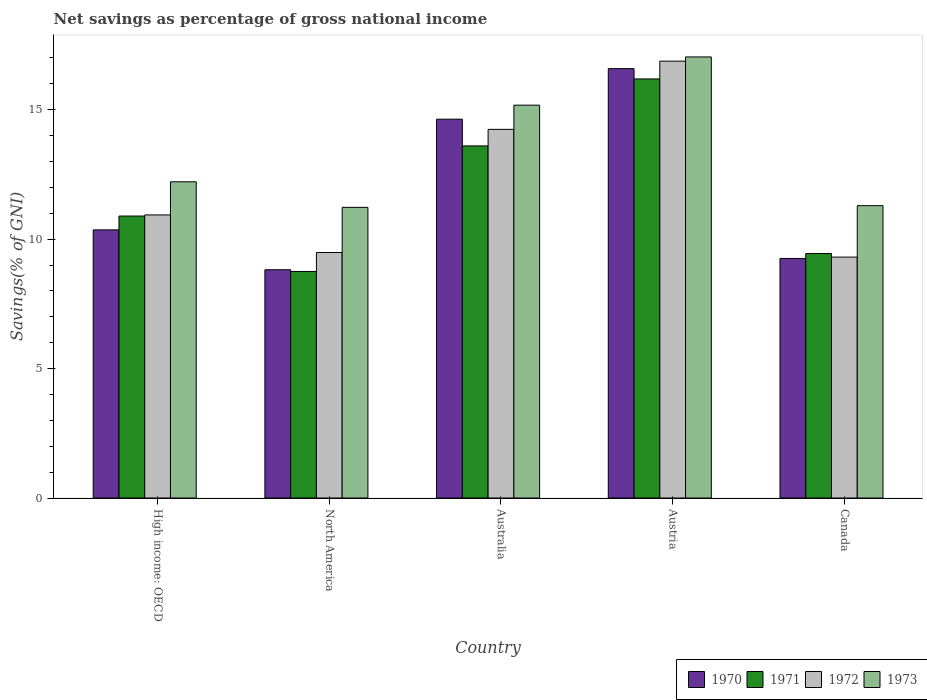How many groups of bars are there?
Your answer should be compact. 5. Are the number of bars per tick equal to the number of legend labels?
Your answer should be compact. Yes. Are the number of bars on each tick of the X-axis equal?
Provide a succinct answer. Yes. How many bars are there on the 2nd tick from the left?
Ensure brevity in your answer.  4. How many bars are there on the 4th tick from the right?
Your answer should be very brief. 4. In how many cases, is the number of bars for a given country not equal to the number of legend labels?
Give a very brief answer. 0. What is the total savings in 1970 in Australia?
Keep it short and to the point. 14.63. Across all countries, what is the maximum total savings in 1970?
Your answer should be very brief. 16.59. Across all countries, what is the minimum total savings in 1971?
Offer a terse response. 8.75. What is the total total savings in 1973 in the graph?
Your response must be concise. 66.95. What is the difference between the total savings in 1972 in Australia and that in Canada?
Give a very brief answer. 4.94. What is the difference between the total savings in 1973 in Australia and the total savings in 1970 in North America?
Your answer should be very brief. 6.36. What is the average total savings in 1971 per country?
Give a very brief answer. 11.78. What is the difference between the total savings of/in 1972 and total savings of/in 1973 in North America?
Your response must be concise. -1.74. What is the ratio of the total savings in 1973 in Australia to that in North America?
Your answer should be very brief. 1.35. Is the total savings in 1973 in Australia less than that in Canada?
Make the answer very short. No. What is the difference between the highest and the second highest total savings in 1970?
Give a very brief answer. 6.23. What is the difference between the highest and the lowest total savings in 1971?
Your answer should be compact. 7.44. Is the sum of the total savings in 1973 in Canada and North America greater than the maximum total savings in 1972 across all countries?
Make the answer very short. Yes. Is it the case that in every country, the sum of the total savings in 1970 and total savings in 1972 is greater than the sum of total savings in 1973 and total savings in 1971?
Your response must be concise. No. How many countries are there in the graph?
Ensure brevity in your answer.  5. What is the difference between two consecutive major ticks on the Y-axis?
Your answer should be very brief. 5. Does the graph contain any zero values?
Make the answer very short. No. Does the graph contain grids?
Your response must be concise. No. Where does the legend appear in the graph?
Offer a terse response. Bottom right. What is the title of the graph?
Keep it short and to the point. Net savings as percentage of gross national income. What is the label or title of the Y-axis?
Your response must be concise. Savings(% of GNI). What is the Savings(% of GNI) of 1970 in High income: OECD?
Your answer should be compact. 10.36. What is the Savings(% of GNI) of 1971 in High income: OECD?
Keep it short and to the point. 10.89. What is the Savings(% of GNI) in 1972 in High income: OECD?
Your answer should be very brief. 10.94. What is the Savings(% of GNI) in 1973 in High income: OECD?
Provide a short and direct response. 12.22. What is the Savings(% of GNI) of 1970 in North America?
Provide a short and direct response. 8.82. What is the Savings(% of GNI) in 1971 in North America?
Provide a succinct answer. 8.75. What is the Savings(% of GNI) of 1972 in North America?
Keep it short and to the point. 9.48. What is the Savings(% of GNI) of 1973 in North America?
Your response must be concise. 11.23. What is the Savings(% of GNI) in 1970 in Australia?
Keep it short and to the point. 14.63. What is the Savings(% of GNI) in 1971 in Australia?
Your answer should be very brief. 13.6. What is the Savings(% of GNI) of 1972 in Australia?
Your response must be concise. 14.24. What is the Savings(% of GNI) of 1973 in Australia?
Your answer should be very brief. 15.18. What is the Savings(% of GNI) in 1970 in Austria?
Offer a terse response. 16.59. What is the Savings(% of GNI) of 1971 in Austria?
Provide a short and direct response. 16.19. What is the Savings(% of GNI) in 1972 in Austria?
Make the answer very short. 16.88. What is the Savings(% of GNI) of 1973 in Austria?
Your response must be concise. 17.04. What is the Savings(% of GNI) in 1970 in Canada?
Ensure brevity in your answer.  9.25. What is the Savings(% of GNI) in 1971 in Canada?
Your response must be concise. 9.45. What is the Savings(% of GNI) of 1972 in Canada?
Make the answer very short. 9.31. What is the Savings(% of GNI) in 1973 in Canada?
Your answer should be very brief. 11.29. Across all countries, what is the maximum Savings(% of GNI) of 1970?
Your answer should be compact. 16.59. Across all countries, what is the maximum Savings(% of GNI) in 1971?
Give a very brief answer. 16.19. Across all countries, what is the maximum Savings(% of GNI) of 1972?
Offer a very short reply. 16.88. Across all countries, what is the maximum Savings(% of GNI) of 1973?
Your response must be concise. 17.04. Across all countries, what is the minimum Savings(% of GNI) of 1970?
Offer a very short reply. 8.82. Across all countries, what is the minimum Savings(% of GNI) of 1971?
Your answer should be very brief. 8.75. Across all countries, what is the minimum Savings(% of GNI) in 1972?
Provide a succinct answer. 9.31. Across all countries, what is the minimum Savings(% of GNI) in 1973?
Keep it short and to the point. 11.23. What is the total Savings(% of GNI) of 1970 in the graph?
Your answer should be compact. 59.65. What is the total Savings(% of GNI) of 1971 in the graph?
Ensure brevity in your answer.  58.88. What is the total Savings(% of GNI) in 1972 in the graph?
Provide a short and direct response. 60.84. What is the total Savings(% of GNI) in 1973 in the graph?
Make the answer very short. 66.95. What is the difference between the Savings(% of GNI) in 1970 in High income: OECD and that in North America?
Keep it short and to the point. 1.54. What is the difference between the Savings(% of GNI) in 1971 in High income: OECD and that in North America?
Make the answer very short. 2.14. What is the difference between the Savings(% of GNI) of 1972 in High income: OECD and that in North America?
Keep it short and to the point. 1.45. What is the difference between the Savings(% of GNI) in 1973 in High income: OECD and that in North America?
Your response must be concise. 0.99. What is the difference between the Savings(% of GNI) in 1970 in High income: OECD and that in Australia?
Offer a terse response. -4.28. What is the difference between the Savings(% of GNI) in 1971 in High income: OECD and that in Australia?
Provide a succinct answer. -2.71. What is the difference between the Savings(% of GNI) of 1972 in High income: OECD and that in Australia?
Give a very brief answer. -3.31. What is the difference between the Savings(% of GNI) in 1973 in High income: OECD and that in Australia?
Give a very brief answer. -2.96. What is the difference between the Savings(% of GNI) of 1970 in High income: OECD and that in Austria?
Offer a terse response. -6.23. What is the difference between the Savings(% of GNI) of 1971 in High income: OECD and that in Austria?
Provide a succinct answer. -5.3. What is the difference between the Savings(% of GNI) in 1972 in High income: OECD and that in Austria?
Keep it short and to the point. -5.94. What is the difference between the Savings(% of GNI) in 1973 in High income: OECD and that in Austria?
Your response must be concise. -4.82. What is the difference between the Savings(% of GNI) in 1970 in High income: OECD and that in Canada?
Provide a short and direct response. 1.1. What is the difference between the Savings(% of GNI) in 1971 in High income: OECD and that in Canada?
Provide a short and direct response. 1.45. What is the difference between the Savings(% of GNI) in 1972 in High income: OECD and that in Canada?
Offer a very short reply. 1.63. What is the difference between the Savings(% of GNI) in 1973 in High income: OECD and that in Canada?
Give a very brief answer. 0.92. What is the difference between the Savings(% of GNI) in 1970 in North America and that in Australia?
Give a very brief answer. -5.82. What is the difference between the Savings(% of GNI) in 1971 in North America and that in Australia?
Ensure brevity in your answer.  -4.85. What is the difference between the Savings(% of GNI) in 1972 in North America and that in Australia?
Give a very brief answer. -4.76. What is the difference between the Savings(% of GNI) in 1973 in North America and that in Australia?
Give a very brief answer. -3.95. What is the difference between the Savings(% of GNI) of 1970 in North America and that in Austria?
Provide a short and direct response. -7.77. What is the difference between the Savings(% of GNI) of 1971 in North America and that in Austria?
Offer a terse response. -7.44. What is the difference between the Savings(% of GNI) in 1972 in North America and that in Austria?
Offer a very short reply. -7.39. What is the difference between the Savings(% of GNI) in 1973 in North America and that in Austria?
Provide a succinct answer. -5.81. What is the difference between the Savings(% of GNI) of 1970 in North America and that in Canada?
Give a very brief answer. -0.44. What is the difference between the Savings(% of GNI) of 1971 in North America and that in Canada?
Provide a short and direct response. -0.69. What is the difference between the Savings(% of GNI) of 1972 in North America and that in Canada?
Offer a very short reply. 0.18. What is the difference between the Savings(% of GNI) in 1973 in North America and that in Canada?
Your answer should be compact. -0.07. What is the difference between the Savings(% of GNI) in 1970 in Australia and that in Austria?
Your answer should be very brief. -1.95. What is the difference between the Savings(% of GNI) in 1971 in Australia and that in Austria?
Provide a succinct answer. -2.59. What is the difference between the Savings(% of GNI) in 1972 in Australia and that in Austria?
Provide a succinct answer. -2.64. What is the difference between the Savings(% of GNI) in 1973 in Australia and that in Austria?
Provide a succinct answer. -1.86. What is the difference between the Savings(% of GNI) in 1970 in Australia and that in Canada?
Provide a succinct answer. 5.38. What is the difference between the Savings(% of GNI) of 1971 in Australia and that in Canada?
Provide a short and direct response. 4.16. What is the difference between the Savings(% of GNI) of 1972 in Australia and that in Canada?
Ensure brevity in your answer.  4.93. What is the difference between the Savings(% of GNI) in 1973 in Australia and that in Canada?
Provide a succinct answer. 3.88. What is the difference between the Savings(% of GNI) of 1970 in Austria and that in Canada?
Ensure brevity in your answer.  7.33. What is the difference between the Savings(% of GNI) of 1971 in Austria and that in Canada?
Ensure brevity in your answer.  6.74. What is the difference between the Savings(% of GNI) in 1972 in Austria and that in Canada?
Offer a terse response. 7.57. What is the difference between the Savings(% of GNI) in 1973 in Austria and that in Canada?
Provide a succinct answer. 5.75. What is the difference between the Savings(% of GNI) of 1970 in High income: OECD and the Savings(% of GNI) of 1971 in North America?
Offer a very short reply. 1.61. What is the difference between the Savings(% of GNI) of 1970 in High income: OECD and the Savings(% of GNI) of 1972 in North America?
Offer a very short reply. 0.87. What is the difference between the Savings(% of GNI) of 1970 in High income: OECD and the Savings(% of GNI) of 1973 in North America?
Provide a short and direct response. -0.87. What is the difference between the Savings(% of GNI) of 1971 in High income: OECD and the Savings(% of GNI) of 1972 in North America?
Your response must be concise. 1.41. What is the difference between the Savings(% of GNI) in 1971 in High income: OECD and the Savings(% of GNI) in 1973 in North America?
Ensure brevity in your answer.  -0.34. What is the difference between the Savings(% of GNI) of 1972 in High income: OECD and the Savings(% of GNI) of 1973 in North America?
Give a very brief answer. -0.29. What is the difference between the Savings(% of GNI) of 1970 in High income: OECD and the Savings(% of GNI) of 1971 in Australia?
Ensure brevity in your answer.  -3.24. What is the difference between the Savings(% of GNI) of 1970 in High income: OECD and the Savings(% of GNI) of 1972 in Australia?
Your answer should be very brief. -3.88. What is the difference between the Savings(% of GNI) of 1970 in High income: OECD and the Savings(% of GNI) of 1973 in Australia?
Provide a short and direct response. -4.82. What is the difference between the Savings(% of GNI) of 1971 in High income: OECD and the Savings(% of GNI) of 1972 in Australia?
Make the answer very short. -3.35. What is the difference between the Savings(% of GNI) in 1971 in High income: OECD and the Savings(% of GNI) in 1973 in Australia?
Keep it short and to the point. -4.28. What is the difference between the Savings(% of GNI) of 1972 in High income: OECD and the Savings(% of GNI) of 1973 in Australia?
Your response must be concise. -4.24. What is the difference between the Savings(% of GNI) of 1970 in High income: OECD and the Savings(% of GNI) of 1971 in Austria?
Your answer should be very brief. -5.83. What is the difference between the Savings(% of GNI) in 1970 in High income: OECD and the Savings(% of GNI) in 1972 in Austria?
Provide a succinct answer. -6.52. What is the difference between the Savings(% of GNI) in 1970 in High income: OECD and the Savings(% of GNI) in 1973 in Austria?
Provide a short and direct response. -6.68. What is the difference between the Savings(% of GNI) in 1971 in High income: OECD and the Savings(% of GNI) in 1972 in Austria?
Offer a very short reply. -5.98. What is the difference between the Savings(% of GNI) in 1971 in High income: OECD and the Savings(% of GNI) in 1973 in Austria?
Give a very brief answer. -6.15. What is the difference between the Savings(% of GNI) of 1972 in High income: OECD and the Savings(% of GNI) of 1973 in Austria?
Your response must be concise. -6.1. What is the difference between the Savings(% of GNI) in 1970 in High income: OECD and the Savings(% of GNI) in 1971 in Canada?
Offer a very short reply. 0.91. What is the difference between the Savings(% of GNI) in 1970 in High income: OECD and the Savings(% of GNI) in 1972 in Canada?
Your answer should be very brief. 1.05. What is the difference between the Savings(% of GNI) in 1970 in High income: OECD and the Savings(% of GNI) in 1973 in Canada?
Offer a terse response. -0.94. What is the difference between the Savings(% of GNI) of 1971 in High income: OECD and the Savings(% of GNI) of 1972 in Canada?
Offer a terse response. 1.59. What is the difference between the Savings(% of GNI) in 1971 in High income: OECD and the Savings(% of GNI) in 1973 in Canada?
Your response must be concise. -0.4. What is the difference between the Savings(% of GNI) of 1972 in High income: OECD and the Savings(% of GNI) of 1973 in Canada?
Your response must be concise. -0.36. What is the difference between the Savings(% of GNI) of 1970 in North America and the Savings(% of GNI) of 1971 in Australia?
Your answer should be compact. -4.78. What is the difference between the Savings(% of GNI) of 1970 in North America and the Savings(% of GNI) of 1972 in Australia?
Keep it short and to the point. -5.42. What is the difference between the Savings(% of GNI) of 1970 in North America and the Savings(% of GNI) of 1973 in Australia?
Make the answer very short. -6.36. What is the difference between the Savings(% of GNI) of 1971 in North America and the Savings(% of GNI) of 1972 in Australia?
Ensure brevity in your answer.  -5.49. What is the difference between the Savings(% of GNI) of 1971 in North America and the Savings(% of GNI) of 1973 in Australia?
Keep it short and to the point. -6.42. What is the difference between the Savings(% of GNI) in 1972 in North America and the Savings(% of GNI) in 1973 in Australia?
Offer a very short reply. -5.69. What is the difference between the Savings(% of GNI) of 1970 in North America and the Savings(% of GNI) of 1971 in Austria?
Offer a very short reply. -7.37. What is the difference between the Savings(% of GNI) of 1970 in North America and the Savings(% of GNI) of 1972 in Austria?
Your answer should be compact. -8.06. What is the difference between the Savings(% of GNI) in 1970 in North America and the Savings(% of GNI) in 1973 in Austria?
Offer a very short reply. -8.22. What is the difference between the Savings(% of GNI) in 1971 in North America and the Savings(% of GNI) in 1972 in Austria?
Your answer should be compact. -8.12. What is the difference between the Savings(% of GNI) in 1971 in North America and the Savings(% of GNI) in 1973 in Austria?
Offer a terse response. -8.29. What is the difference between the Savings(% of GNI) in 1972 in North America and the Savings(% of GNI) in 1973 in Austria?
Offer a terse response. -7.56. What is the difference between the Savings(% of GNI) in 1970 in North America and the Savings(% of GNI) in 1971 in Canada?
Provide a short and direct response. -0.63. What is the difference between the Savings(% of GNI) in 1970 in North America and the Savings(% of GNI) in 1972 in Canada?
Make the answer very short. -0.49. What is the difference between the Savings(% of GNI) in 1970 in North America and the Savings(% of GNI) in 1973 in Canada?
Offer a very short reply. -2.48. What is the difference between the Savings(% of GNI) of 1971 in North America and the Savings(% of GNI) of 1972 in Canada?
Give a very brief answer. -0.55. What is the difference between the Savings(% of GNI) in 1971 in North America and the Savings(% of GNI) in 1973 in Canada?
Your response must be concise. -2.54. What is the difference between the Savings(% of GNI) in 1972 in North America and the Savings(% of GNI) in 1973 in Canada?
Your answer should be very brief. -1.81. What is the difference between the Savings(% of GNI) in 1970 in Australia and the Savings(% of GNI) in 1971 in Austria?
Make the answer very short. -1.55. What is the difference between the Savings(% of GNI) in 1970 in Australia and the Savings(% of GNI) in 1972 in Austria?
Offer a very short reply. -2.24. What is the difference between the Savings(% of GNI) in 1970 in Australia and the Savings(% of GNI) in 1973 in Austria?
Provide a short and direct response. -2.4. What is the difference between the Savings(% of GNI) in 1971 in Australia and the Savings(% of GNI) in 1972 in Austria?
Provide a succinct answer. -3.27. What is the difference between the Savings(% of GNI) in 1971 in Australia and the Savings(% of GNI) in 1973 in Austria?
Give a very brief answer. -3.44. What is the difference between the Savings(% of GNI) of 1972 in Australia and the Savings(% of GNI) of 1973 in Austria?
Your answer should be compact. -2.8. What is the difference between the Savings(% of GNI) in 1970 in Australia and the Savings(% of GNI) in 1971 in Canada?
Keep it short and to the point. 5.19. What is the difference between the Savings(% of GNI) in 1970 in Australia and the Savings(% of GNI) in 1972 in Canada?
Provide a succinct answer. 5.33. What is the difference between the Savings(% of GNI) in 1970 in Australia and the Savings(% of GNI) in 1973 in Canada?
Provide a short and direct response. 3.34. What is the difference between the Savings(% of GNI) in 1971 in Australia and the Savings(% of GNI) in 1972 in Canada?
Ensure brevity in your answer.  4.3. What is the difference between the Savings(% of GNI) in 1971 in Australia and the Savings(% of GNI) in 1973 in Canada?
Provide a short and direct response. 2.31. What is the difference between the Savings(% of GNI) in 1972 in Australia and the Savings(% of GNI) in 1973 in Canada?
Keep it short and to the point. 2.95. What is the difference between the Savings(% of GNI) in 1970 in Austria and the Savings(% of GNI) in 1971 in Canada?
Make the answer very short. 7.14. What is the difference between the Savings(% of GNI) of 1970 in Austria and the Savings(% of GNI) of 1972 in Canada?
Offer a terse response. 7.28. What is the difference between the Savings(% of GNI) in 1970 in Austria and the Savings(% of GNI) in 1973 in Canada?
Provide a succinct answer. 5.29. What is the difference between the Savings(% of GNI) of 1971 in Austria and the Savings(% of GNI) of 1972 in Canada?
Offer a terse response. 6.88. What is the difference between the Savings(% of GNI) in 1971 in Austria and the Savings(% of GNI) in 1973 in Canada?
Keep it short and to the point. 4.9. What is the difference between the Savings(% of GNI) of 1972 in Austria and the Savings(% of GNI) of 1973 in Canada?
Keep it short and to the point. 5.58. What is the average Savings(% of GNI) of 1970 per country?
Keep it short and to the point. 11.93. What is the average Savings(% of GNI) of 1971 per country?
Your answer should be compact. 11.78. What is the average Savings(% of GNI) in 1972 per country?
Your answer should be very brief. 12.17. What is the average Savings(% of GNI) in 1973 per country?
Provide a short and direct response. 13.39. What is the difference between the Savings(% of GNI) in 1970 and Savings(% of GNI) in 1971 in High income: OECD?
Provide a short and direct response. -0.53. What is the difference between the Savings(% of GNI) of 1970 and Savings(% of GNI) of 1972 in High income: OECD?
Ensure brevity in your answer.  -0.58. What is the difference between the Savings(% of GNI) of 1970 and Savings(% of GNI) of 1973 in High income: OECD?
Ensure brevity in your answer.  -1.86. What is the difference between the Savings(% of GNI) of 1971 and Savings(% of GNI) of 1972 in High income: OECD?
Ensure brevity in your answer.  -0.04. What is the difference between the Savings(% of GNI) in 1971 and Savings(% of GNI) in 1973 in High income: OECD?
Make the answer very short. -1.32. What is the difference between the Savings(% of GNI) of 1972 and Savings(% of GNI) of 1973 in High income: OECD?
Your answer should be very brief. -1.28. What is the difference between the Savings(% of GNI) in 1970 and Savings(% of GNI) in 1971 in North America?
Keep it short and to the point. 0.07. What is the difference between the Savings(% of GNI) in 1970 and Savings(% of GNI) in 1972 in North America?
Offer a terse response. -0.67. What is the difference between the Savings(% of GNI) of 1970 and Savings(% of GNI) of 1973 in North America?
Offer a terse response. -2.41. What is the difference between the Savings(% of GNI) of 1971 and Savings(% of GNI) of 1972 in North America?
Your answer should be very brief. -0.73. What is the difference between the Savings(% of GNI) of 1971 and Savings(% of GNI) of 1973 in North America?
Ensure brevity in your answer.  -2.48. What is the difference between the Savings(% of GNI) of 1972 and Savings(% of GNI) of 1973 in North America?
Provide a succinct answer. -1.74. What is the difference between the Savings(% of GNI) in 1970 and Savings(% of GNI) in 1971 in Australia?
Your answer should be very brief. 1.03. What is the difference between the Savings(% of GNI) in 1970 and Savings(% of GNI) in 1972 in Australia?
Offer a terse response. 0.39. What is the difference between the Savings(% of GNI) of 1970 and Savings(% of GNI) of 1973 in Australia?
Your response must be concise. -0.54. What is the difference between the Savings(% of GNI) in 1971 and Savings(% of GNI) in 1972 in Australia?
Offer a very short reply. -0.64. What is the difference between the Savings(% of GNI) in 1971 and Savings(% of GNI) in 1973 in Australia?
Your answer should be very brief. -1.57. What is the difference between the Savings(% of GNI) of 1972 and Savings(% of GNI) of 1973 in Australia?
Offer a very short reply. -0.93. What is the difference between the Savings(% of GNI) in 1970 and Savings(% of GNI) in 1971 in Austria?
Ensure brevity in your answer.  0.4. What is the difference between the Savings(% of GNI) in 1970 and Savings(% of GNI) in 1972 in Austria?
Keep it short and to the point. -0.29. What is the difference between the Savings(% of GNI) in 1970 and Savings(% of GNI) in 1973 in Austria?
Keep it short and to the point. -0.45. What is the difference between the Savings(% of GNI) of 1971 and Savings(% of GNI) of 1972 in Austria?
Keep it short and to the point. -0.69. What is the difference between the Savings(% of GNI) in 1971 and Savings(% of GNI) in 1973 in Austria?
Make the answer very short. -0.85. What is the difference between the Savings(% of GNI) in 1972 and Savings(% of GNI) in 1973 in Austria?
Provide a succinct answer. -0.16. What is the difference between the Savings(% of GNI) of 1970 and Savings(% of GNI) of 1971 in Canada?
Your response must be concise. -0.19. What is the difference between the Savings(% of GNI) in 1970 and Savings(% of GNI) in 1972 in Canada?
Offer a terse response. -0.05. What is the difference between the Savings(% of GNI) of 1970 and Savings(% of GNI) of 1973 in Canada?
Provide a short and direct response. -2.04. What is the difference between the Savings(% of GNI) in 1971 and Savings(% of GNI) in 1972 in Canada?
Ensure brevity in your answer.  0.14. What is the difference between the Savings(% of GNI) in 1971 and Savings(% of GNI) in 1973 in Canada?
Your answer should be very brief. -1.85. What is the difference between the Savings(% of GNI) of 1972 and Savings(% of GNI) of 1973 in Canada?
Make the answer very short. -1.99. What is the ratio of the Savings(% of GNI) of 1970 in High income: OECD to that in North America?
Ensure brevity in your answer.  1.17. What is the ratio of the Savings(% of GNI) of 1971 in High income: OECD to that in North America?
Your answer should be compact. 1.24. What is the ratio of the Savings(% of GNI) of 1972 in High income: OECD to that in North America?
Provide a short and direct response. 1.15. What is the ratio of the Savings(% of GNI) in 1973 in High income: OECD to that in North America?
Keep it short and to the point. 1.09. What is the ratio of the Savings(% of GNI) in 1970 in High income: OECD to that in Australia?
Provide a short and direct response. 0.71. What is the ratio of the Savings(% of GNI) of 1971 in High income: OECD to that in Australia?
Make the answer very short. 0.8. What is the ratio of the Savings(% of GNI) of 1972 in High income: OECD to that in Australia?
Give a very brief answer. 0.77. What is the ratio of the Savings(% of GNI) of 1973 in High income: OECD to that in Australia?
Make the answer very short. 0.8. What is the ratio of the Savings(% of GNI) of 1970 in High income: OECD to that in Austria?
Your answer should be compact. 0.62. What is the ratio of the Savings(% of GNI) of 1971 in High income: OECD to that in Austria?
Ensure brevity in your answer.  0.67. What is the ratio of the Savings(% of GNI) of 1972 in High income: OECD to that in Austria?
Ensure brevity in your answer.  0.65. What is the ratio of the Savings(% of GNI) of 1973 in High income: OECD to that in Austria?
Offer a very short reply. 0.72. What is the ratio of the Savings(% of GNI) of 1970 in High income: OECD to that in Canada?
Ensure brevity in your answer.  1.12. What is the ratio of the Savings(% of GNI) of 1971 in High income: OECD to that in Canada?
Give a very brief answer. 1.15. What is the ratio of the Savings(% of GNI) in 1972 in High income: OECD to that in Canada?
Make the answer very short. 1.18. What is the ratio of the Savings(% of GNI) of 1973 in High income: OECD to that in Canada?
Your answer should be compact. 1.08. What is the ratio of the Savings(% of GNI) in 1970 in North America to that in Australia?
Ensure brevity in your answer.  0.6. What is the ratio of the Savings(% of GNI) of 1971 in North America to that in Australia?
Your answer should be very brief. 0.64. What is the ratio of the Savings(% of GNI) in 1972 in North America to that in Australia?
Make the answer very short. 0.67. What is the ratio of the Savings(% of GNI) of 1973 in North America to that in Australia?
Offer a terse response. 0.74. What is the ratio of the Savings(% of GNI) in 1970 in North America to that in Austria?
Your answer should be very brief. 0.53. What is the ratio of the Savings(% of GNI) in 1971 in North America to that in Austria?
Offer a very short reply. 0.54. What is the ratio of the Savings(% of GNI) in 1972 in North America to that in Austria?
Make the answer very short. 0.56. What is the ratio of the Savings(% of GNI) in 1973 in North America to that in Austria?
Provide a succinct answer. 0.66. What is the ratio of the Savings(% of GNI) of 1970 in North America to that in Canada?
Offer a terse response. 0.95. What is the ratio of the Savings(% of GNI) of 1971 in North America to that in Canada?
Your answer should be very brief. 0.93. What is the ratio of the Savings(% of GNI) in 1972 in North America to that in Canada?
Ensure brevity in your answer.  1.02. What is the ratio of the Savings(% of GNI) in 1970 in Australia to that in Austria?
Offer a very short reply. 0.88. What is the ratio of the Savings(% of GNI) of 1971 in Australia to that in Austria?
Offer a terse response. 0.84. What is the ratio of the Savings(% of GNI) of 1972 in Australia to that in Austria?
Provide a short and direct response. 0.84. What is the ratio of the Savings(% of GNI) in 1973 in Australia to that in Austria?
Your answer should be very brief. 0.89. What is the ratio of the Savings(% of GNI) of 1970 in Australia to that in Canada?
Ensure brevity in your answer.  1.58. What is the ratio of the Savings(% of GNI) of 1971 in Australia to that in Canada?
Give a very brief answer. 1.44. What is the ratio of the Savings(% of GNI) of 1972 in Australia to that in Canada?
Ensure brevity in your answer.  1.53. What is the ratio of the Savings(% of GNI) of 1973 in Australia to that in Canada?
Your answer should be compact. 1.34. What is the ratio of the Savings(% of GNI) of 1970 in Austria to that in Canada?
Your response must be concise. 1.79. What is the ratio of the Savings(% of GNI) in 1971 in Austria to that in Canada?
Your answer should be compact. 1.71. What is the ratio of the Savings(% of GNI) of 1972 in Austria to that in Canada?
Provide a succinct answer. 1.81. What is the ratio of the Savings(% of GNI) of 1973 in Austria to that in Canada?
Ensure brevity in your answer.  1.51. What is the difference between the highest and the second highest Savings(% of GNI) in 1970?
Keep it short and to the point. 1.95. What is the difference between the highest and the second highest Savings(% of GNI) in 1971?
Ensure brevity in your answer.  2.59. What is the difference between the highest and the second highest Savings(% of GNI) of 1972?
Keep it short and to the point. 2.64. What is the difference between the highest and the second highest Savings(% of GNI) in 1973?
Offer a very short reply. 1.86. What is the difference between the highest and the lowest Savings(% of GNI) in 1970?
Give a very brief answer. 7.77. What is the difference between the highest and the lowest Savings(% of GNI) of 1971?
Keep it short and to the point. 7.44. What is the difference between the highest and the lowest Savings(% of GNI) in 1972?
Your response must be concise. 7.57. What is the difference between the highest and the lowest Savings(% of GNI) of 1973?
Provide a succinct answer. 5.81. 